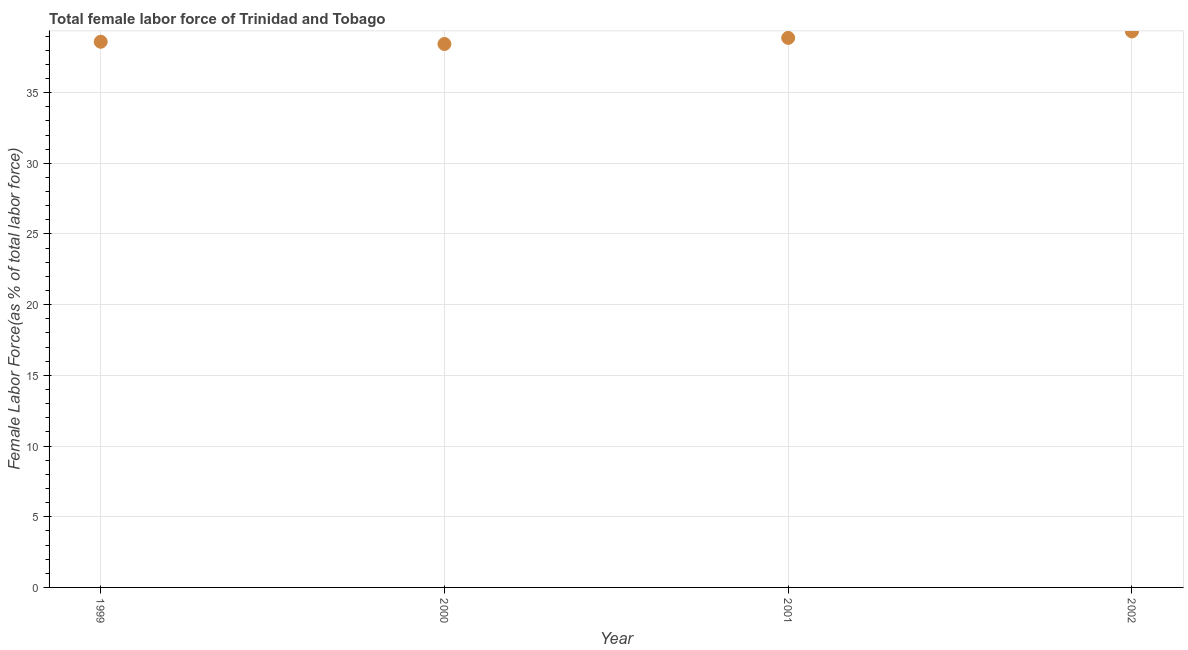What is the total female labor force in 2000?
Your answer should be very brief. 38.44. Across all years, what is the maximum total female labor force?
Your response must be concise. 39.33. Across all years, what is the minimum total female labor force?
Make the answer very short. 38.44. What is the sum of the total female labor force?
Your answer should be very brief. 155.24. What is the difference between the total female labor force in 2001 and 2002?
Your answer should be compact. -0.45. What is the average total female labor force per year?
Offer a terse response. 38.81. What is the median total female labor force?
Your answer should be very brief. 38.74. In how many years, is the total female labor force greater than 35 %?
Provide a succinct answer. 4. Do a majority of the years between 1999 and 2002 (inclusive) have total female labor force greater than 12 %?
Keep it short and to the point. Yes. What is the ratio of the total female labor force in 2000 to that in 2001?
Provide a succinct answer. 0.99. Is the difference between the total female labor force in 2000 and 2002 greater than the difference between any two years?
Offer a very short reply. Yes. What is the difference between the highest and the second highest total female labor force?
Offer a very short reply. 0.45. Is the sum of the total female labor force in 2000 and 2001 greater than the maximum total female labor force across all years?
Keep it short and to the point. Yes. What is the difference between the highest and the lowest total female labor force?
Provide a succinct answer. 0.89. Does the total female labor force monotonically increase over the years?
Make the answer very short. No. How many years are there in the graph?
Your response must be concise. 4. What is the difference between two consecutive major ticks on the Y-axis?
Provide a succinct answer. 5. Are the values on the major ticks of Y-axis written in scientific E-notation?
Your response must be concise. No. Does the graph contain grids?
Offer a very short reply. Yes. What is the title of the graph?
Provide a succinct answer. Total female labor force of Trinidad and Tobago. What is the label or title of the Y-axis?
Offer a very short reply. Female Labor Force(as % of total labor force). What is the Female Labor Force(as % of total labor force) in 1999?
Make the answer very short. 38.6. What is the Female Labor Force(as % of total labor force) in 2000?
Your response must be concise. 38.44. What is the Female Labor Force(as % of total labor force) in 2001?
Offer a terse response. 38.87. What is the Female Labor Force(as % of total labor force) in 2002?
Keep it short and to the point. 39.33. What is the difference between the Female Labor Force(as % of total labor force) in 1999 and 2000?
Keep it short and to the point. 0.16. What is the difference between the Female Labor Force(as % of total labor force) in 1999 and 2001?
Your answer should be compact. -0.27. What is the difference between the Female Labor Force(as % of total labor force) in 1999 and 2002?
Ensure brevity in your answer.  -0.73. What is the difference between the Female Labor Force(as % of total labor force) in 2000 and 2001?
Give a very brief answer. -0.43. What is the difference between the Female Labor Force(as % of total labor force) in 2000 and 2002?
Ensure brevity in your answer.  -0.89. What is the difference between the Female Labor Force(as % of total labor force) in 2001 and 2002?
Provide a short and direct response. -0.45. What is the ratio of the Female Labor Force(as % of total labor force) in 1999 to that in 2001?
Ensure brevity in your answer.  0.99. What is the ratio of the Female Labor Force(as % of total labor force) in 1999 to that in 2002?
Offer a very short reply. 0.98. What is the ratio of the Female Labor Force(as % of total labor force) in 2000 to that in 2001?
Your answer should be compact. 0.99. What is the ratio of the Female Labor Force(as % of total labor force) in 2000 to that in 2002?
Provide a succinct answer. 0.98. What is the ratio of the Female Labor Force(as % of total labor force) in 2001 to that in 2002?
Ensure brevity in your answer.  0.99. 